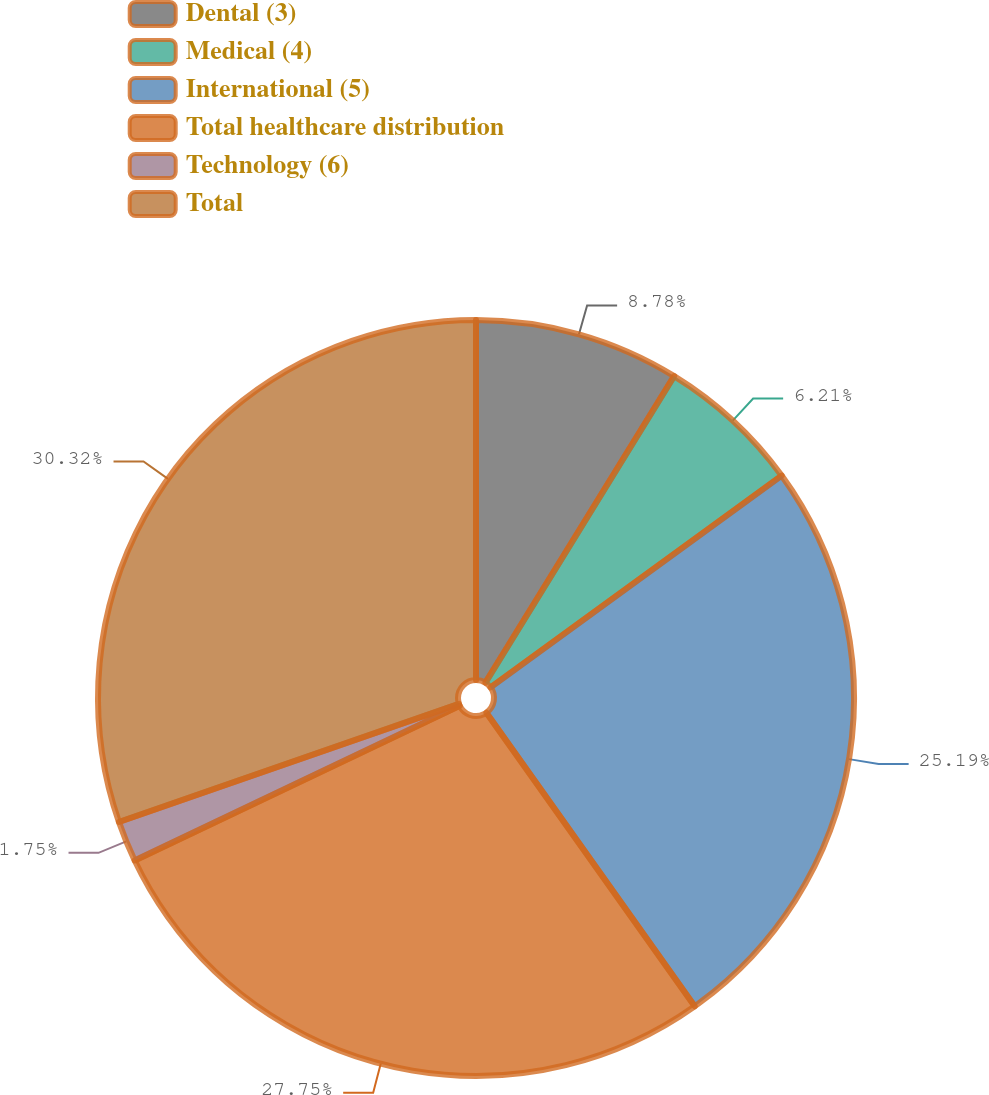Convert chart to OTSL. <chart><loc_0><loc_0><loc_500><loc_500><pie_chart><fcel>Dental (3)<fcel>Medical (4)<fcel>International (5)<fcel>Total healthcare distribution<fcel>Technology (6)<fcel>Total<nl><fcel>8.78%<fcel>6.21%<fcel>25.19%<fcel>27.75%<fcel>1.75%<fcel>30.32%<nl></chart> 